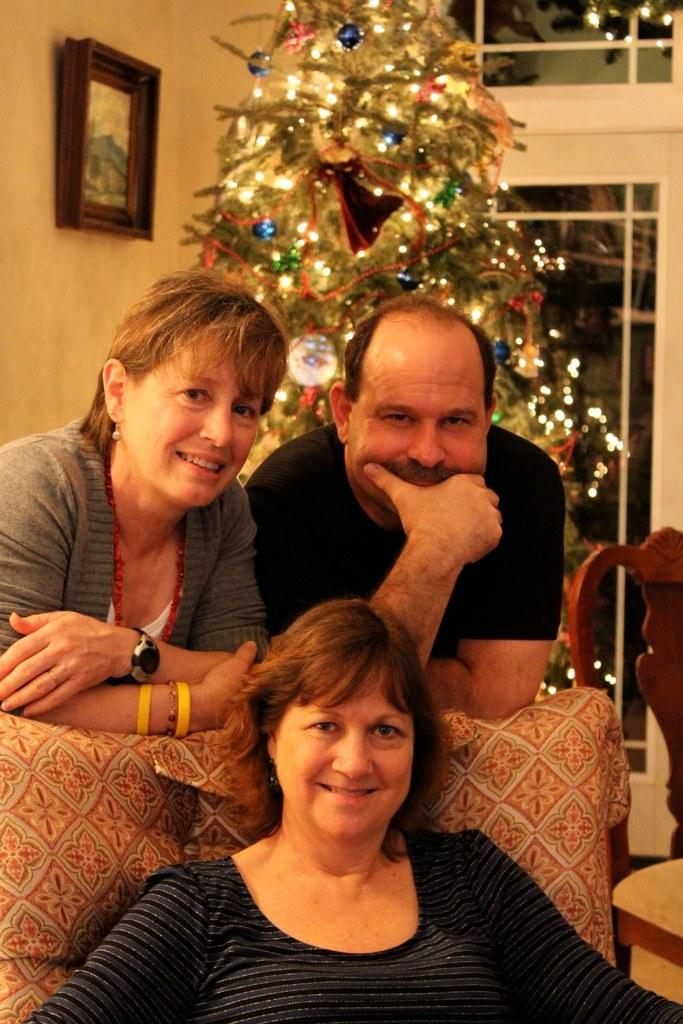How many people are in the image? There are people in the image, but the exact number is not specified. What type of furniture is present in the image? There are chairs in the image. What natural element can be seen in the image? There is a tree in the image. What is hanging on the wall in the image? There is a picture on the wall in the image. What type of structure is visible in the image? There is a wall in the image. What type of illumination is present in the image? There are lights in the image. What else can be seen in the image besides the people and chairs? There are objects in the image. What is one person doing in the image? One person is sitting on a chair in the image. What type of iron is being used by the person in the image? There is no iron present in the image. What insect can be seen crawling on the person in the image? There are no insects present in the image. 